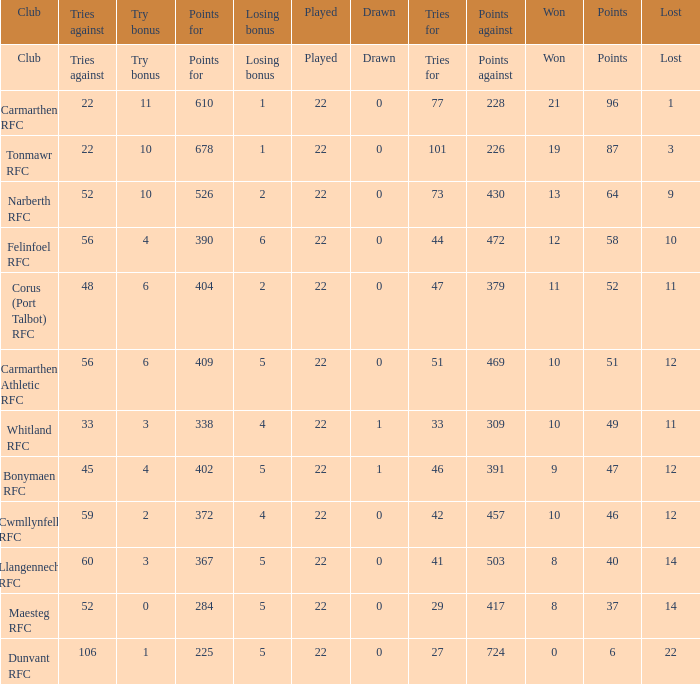Name the tries against for 87 points 22.0. 